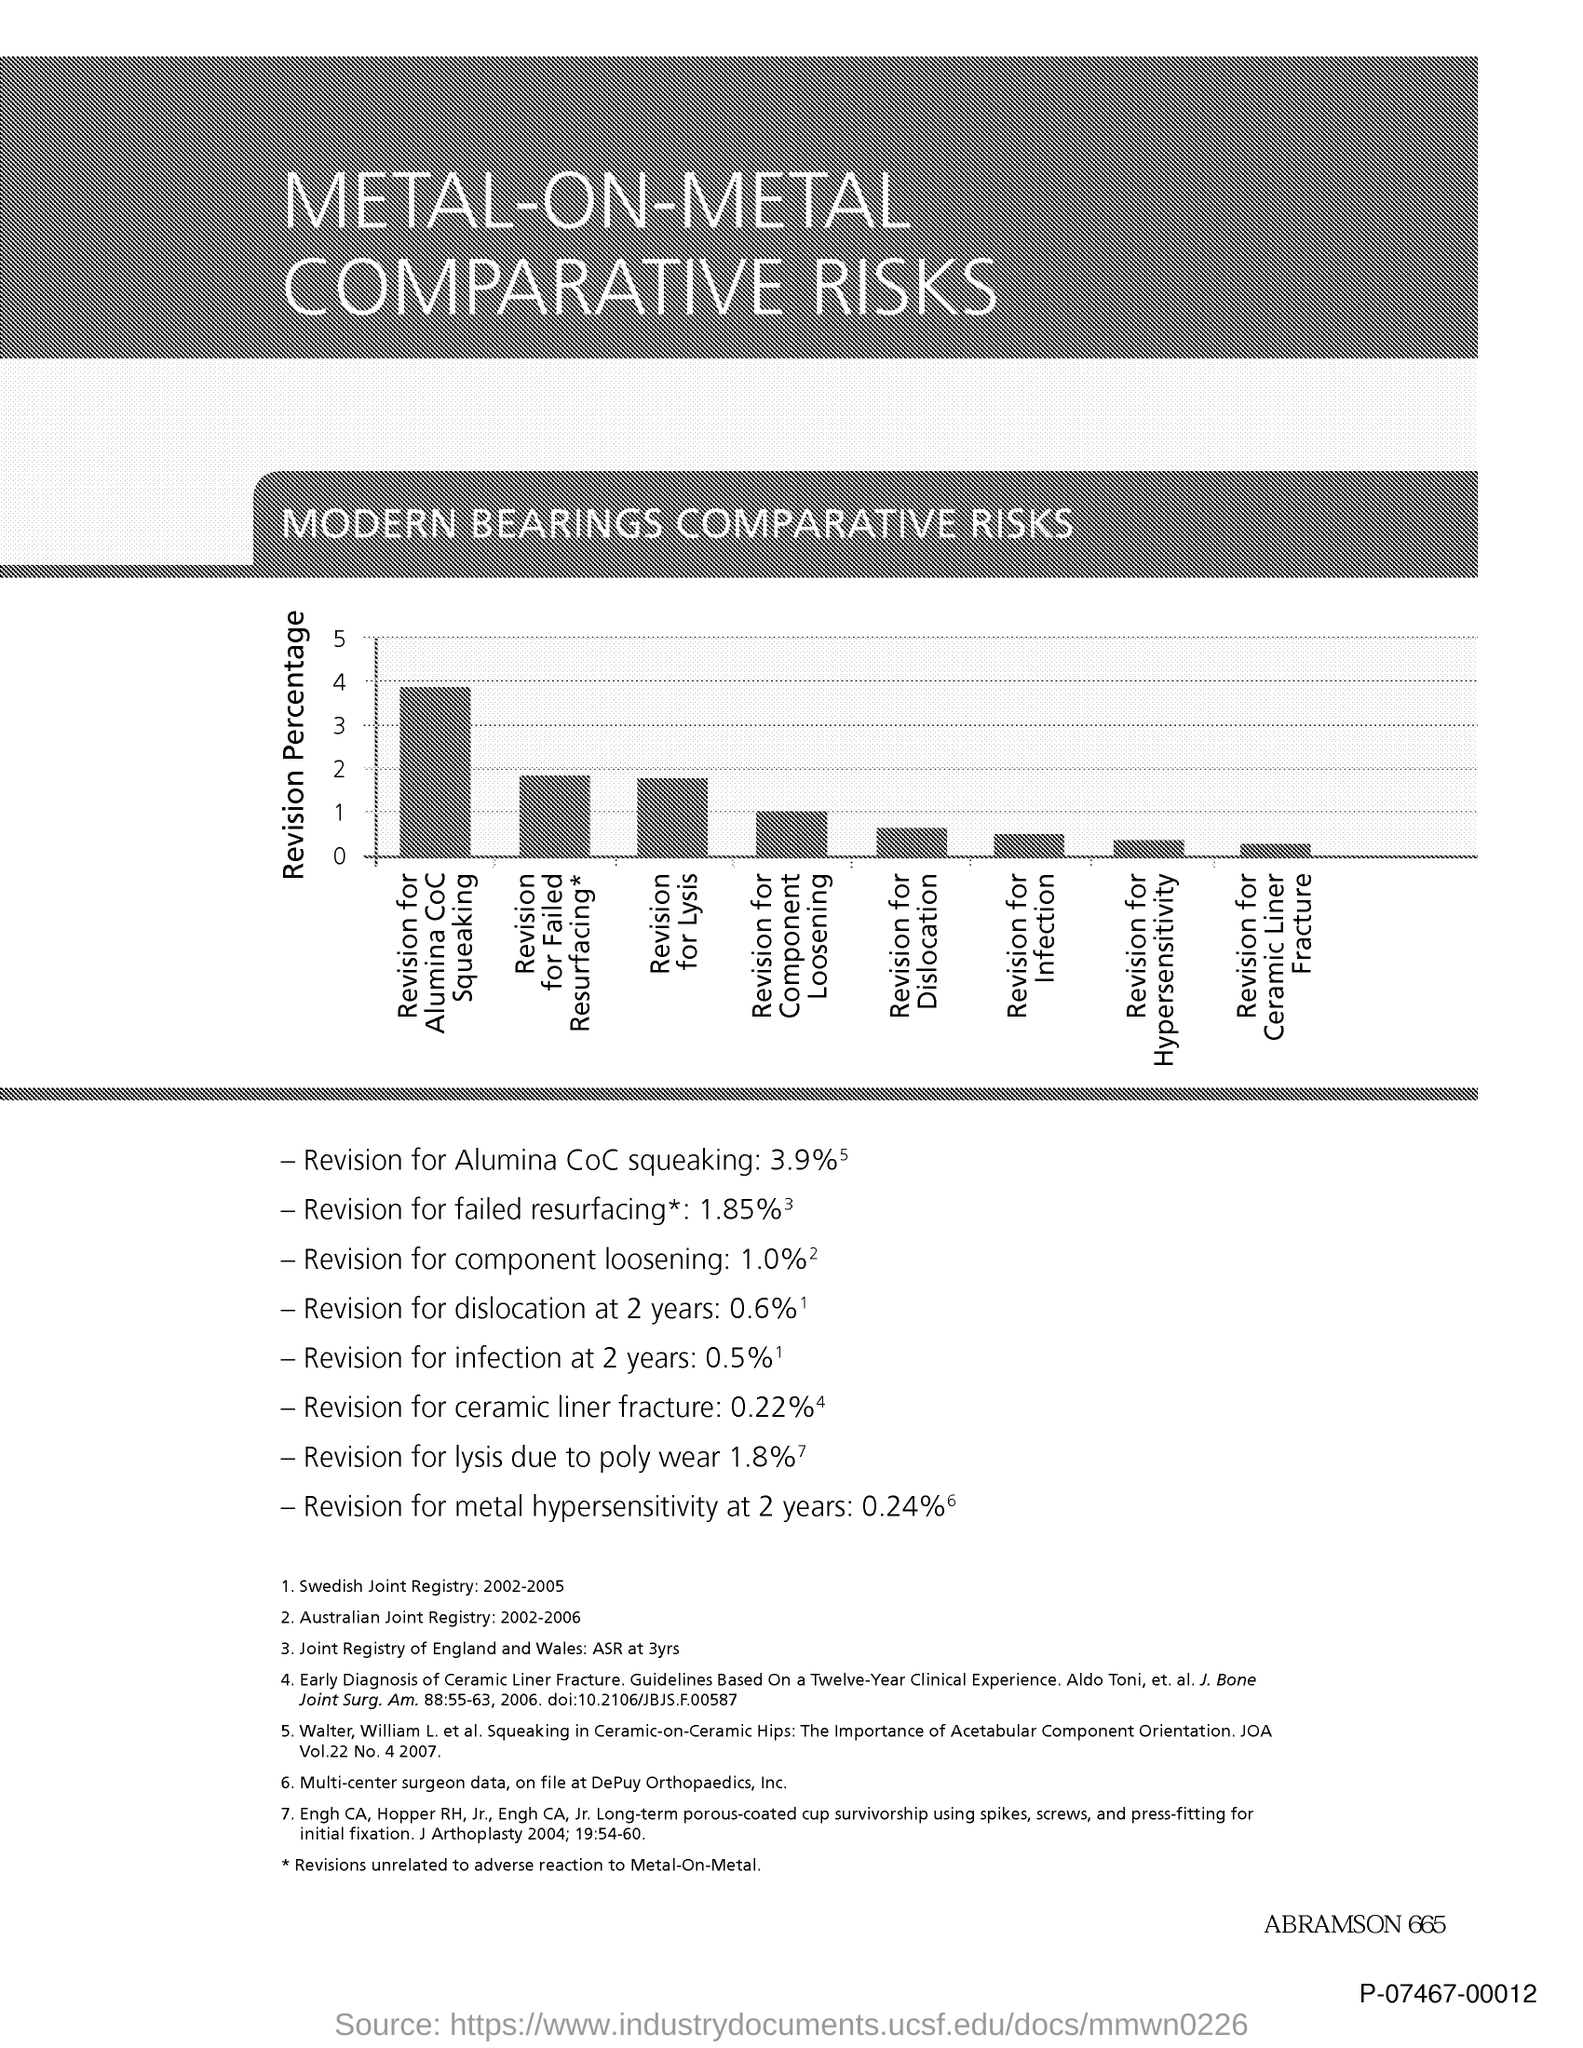What is the title of the document?
Your answer should be compact. Metal-on-metal comparative risks. What is plotted in the y-axis?
Ensure brevity in your answer.  Revision Percentage. What is the second title in this document?
Your answer should be compact. Modern Bearings Comparative Risks. 